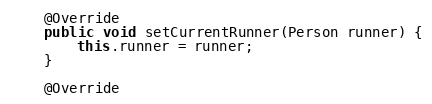<code> <loc_0><loc_0><loc_500><loc_500><_Java_>    @Override
    public void setCurrentRunner(Person runner) {
        this.runner = runner;
    }

    @Override</code> 